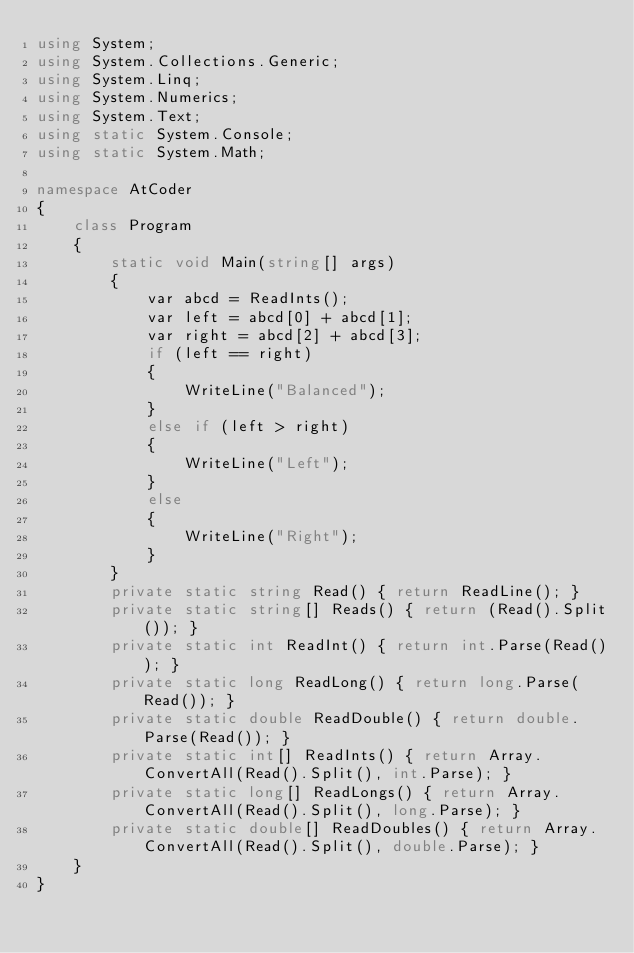Convert code to text. <code><loc_0><loc_0><loc_500><loc_500><_C#_>using System;
using System.Collections.Generic;
using System.Linq;
using System.Numerics;
using System.Text;
using static System.Console;
using static System.Math;

namespace AtCoder
{
    class Program
    {
        static void Main(string[] args)
        {
            var abcd = ReadInts();
            var left = abcd[0] + abcd[1];
            var right = abcd[2] + abcd[3];
            if (left == right)
            {
                WriteLine("Balanced");
            }
            else if (left > right)
            {
                WriteLine("Left");
            }
            else
            {
                WriteLine("Right");
            }
        }
        private static string Read() { return ReadLine(); }
        private static string[] Reads() { return (Read().Split()); }
        private static int ReadInt() { return int.Parse(Read()); }
        private static long ReadLong() { return long.Parse(Read()); }
        private static double ReadDouble() { return double.Parse(Read()); }
        private static int[] ReadInts() { return Array.ConvertAll(Read().Split(), int.Parse); }
        private static long[] ReadLongs() { return Array.ConvertAll(Read().Split(), long.Parse); }
        private static double[] ReadDoubles() { return Array.ConvertAll(Read().Split(), double.Parse); }
    }
}
</code> 